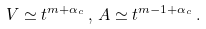<formula> <loc_0><loc_0><loc_500><loc_500>V \simeq t ^ { m + \alpha _ { c } } \, , \, A \simeq t ^ { m - 1 + \alpha _ { c } } \, .</formula> 